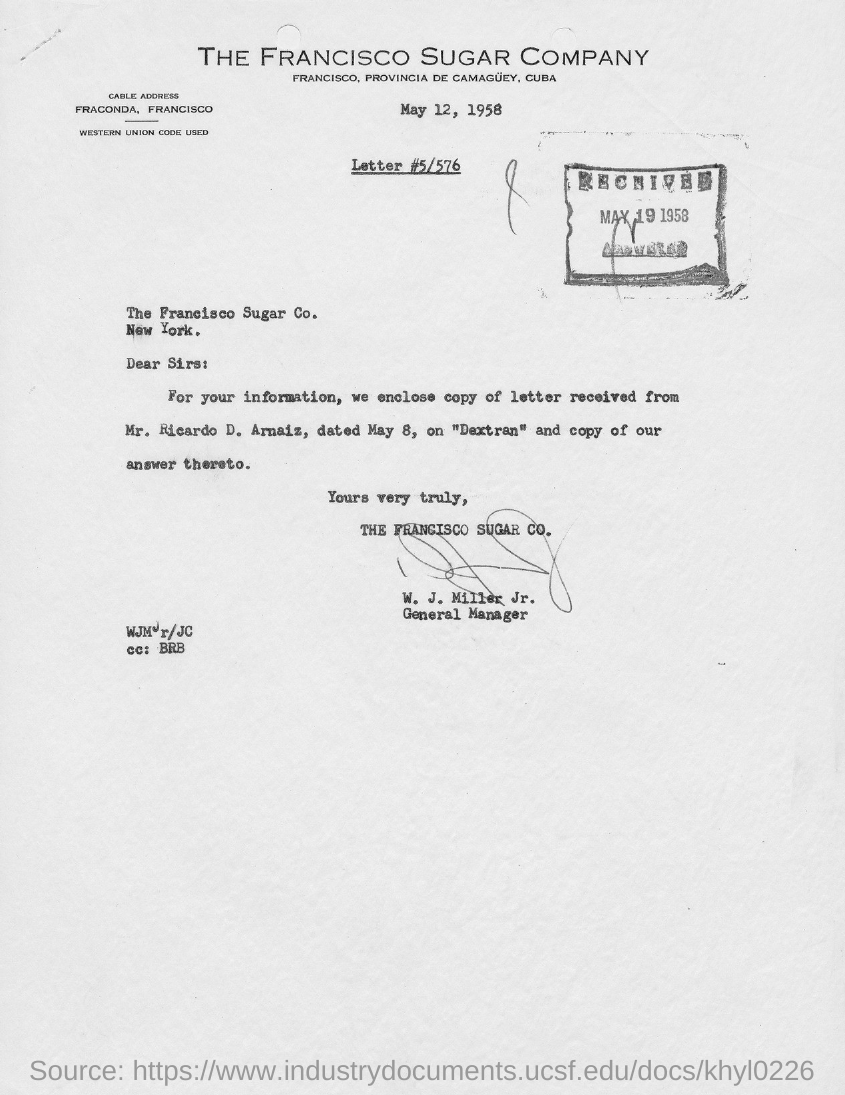Highlight a few significant elements in this photo. The letter was signed by William J. Miller Jr. The received date of this letter is May 19, 1958. The Francisco Sugar Company is mentioned in the letterhead. To my knowledge, the letter with the number  #(no) has not been assigned a value. W. J. Miller, Jr.'s designation is General Manager. 